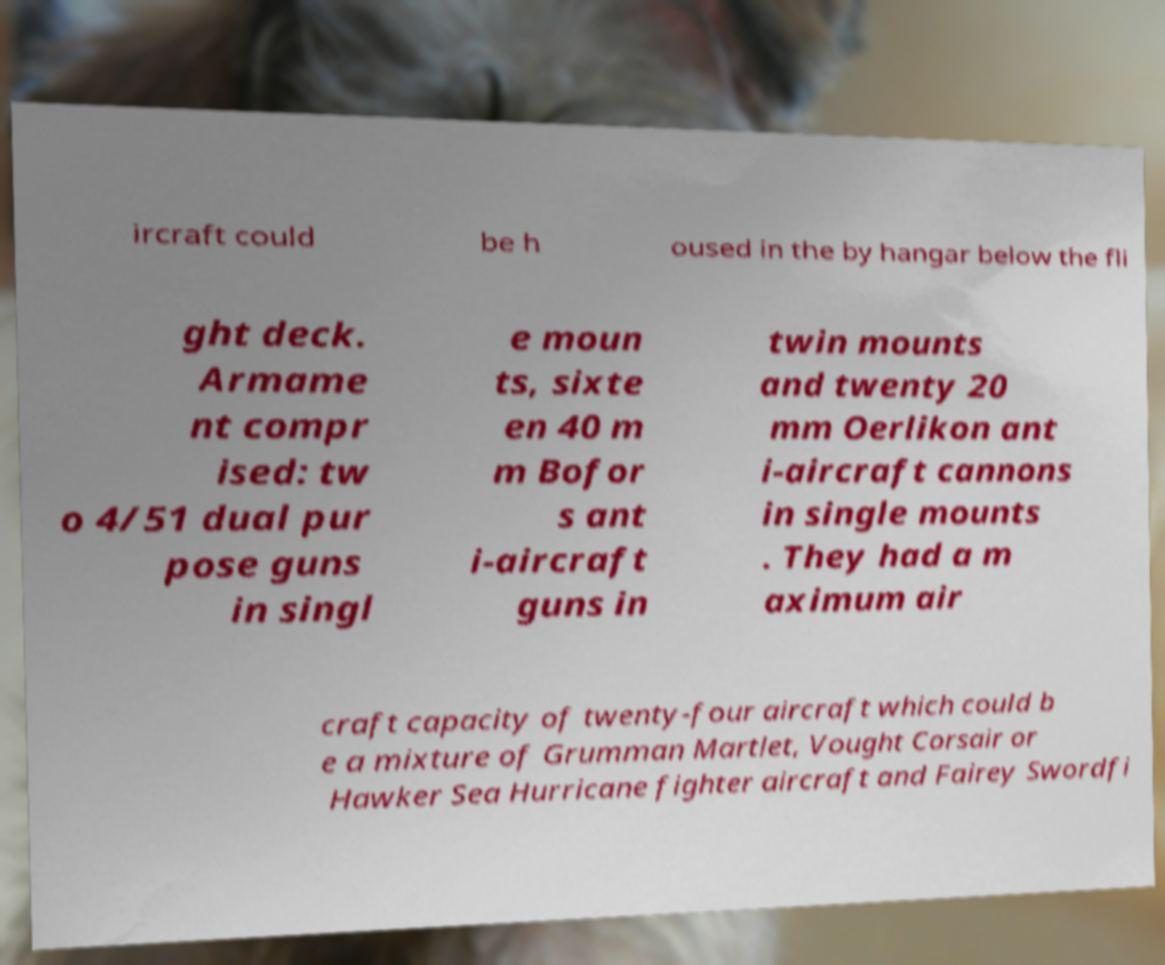There's text embedded in this image that I need extracted. Can you transcribe it verbatim? ircraft could be h oused in the by hangar below the fli ght deck. Armame nt compr ised: tw o 4/51 dual pur pose guns in singl e moun ts, sixte en 40 m m Bofor s ant i-aircraft guns in twin mounts and twenty 20 mm Oerlikon ant i-aircraft cannons in single mounts . They had a m aximum air craft capacity of twenty-four aircraft which could b e a mixture of Grumman Martlet, Vought Corsair or Hawker Sea Hurricane fighter aircraft and Fairey Swordfi 